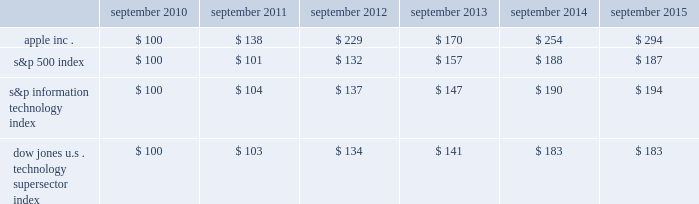Table of contents company stock performance the following graph shows a comparison of cumulative total shareholder return , calculated on a dividend reinvested basis , for the company , the s&p 500 index , the s&p information technology index and the dow jones u.s .
Technology supersector index for the five years ended september 26 , 2015 .
The graph assumes $ 100 was invested in each of the company 2019s common stock , the s&p 500 index , the s&p information technology index and the dow jones u.s .
Technology supersector index as of the market close on september 24 , 2010 .
Note that historic stock price performance is not necessarily indicative of future stock price performance .
* $ 100 invested on 9/25/10 in stock or index , including reinvestment of dividends .
Data points are the last day of each fiscal year for the company 2019scommon stock and september 30th for indexes .
Copyright a9 2015 s&p , a division of mcgraw hill financial .
All rights reserved .
Copyright a9 2015 dow jones & co .
All rights reserved .
September september september september september september .
Apple inc .
| 2015 form 10-k | 21 .
What was the percentage cumulative total shareholder return for the four years ended 2014? 
Computations: ((254 - 100) / 100)
Answer: 1.54. Table of contents company stock performance the following graph shows a comparison of cumulative total shareholder return , calculated on a dividend reinvested basis , for the company , the s&p 500 index , the s&p information technology index and the dow jones u.s .
Technology supersector index for the five years ended september 26 , 2015 .
The graph assumes $ 100 was invested in each of the company 2019s common stock , the s&p 500 index , the s&p information technology index and the dow jones u.s .
Technology supersector index as of the market close on september 24 , 2010 .
Note that historic stock price performance is not necessarily indicative of future stock price performance .
* $ 100 invested on 9/25/10 in stock or index , including reinvestment of dividends .
Data points are the last day of each fiscal year for the company 2019scommon stock and september 30th for indexes .
Copyright a9 2015 s&p , a division of mcgraw hill financial .
All rights reserved .
Copyright a9 2015 dow jones & co .
All rights reserved .
September september september september september september .
Apple inc .
| 2015 form 10-k | 21 .
What was the change in the s&p 500 index between 2010 and 2015? 
Computations: (187 - 100)
Answer: 87.0. 